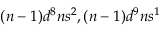Convert formula to latex. <formula><loc_0><loc_0><loc_500><loc_500>( n - 1 ) d ^ { 8 } n s ^ { 2 } , ( n - 1 ) d ^ { 9 } n s ^ { 1 }</formula> 